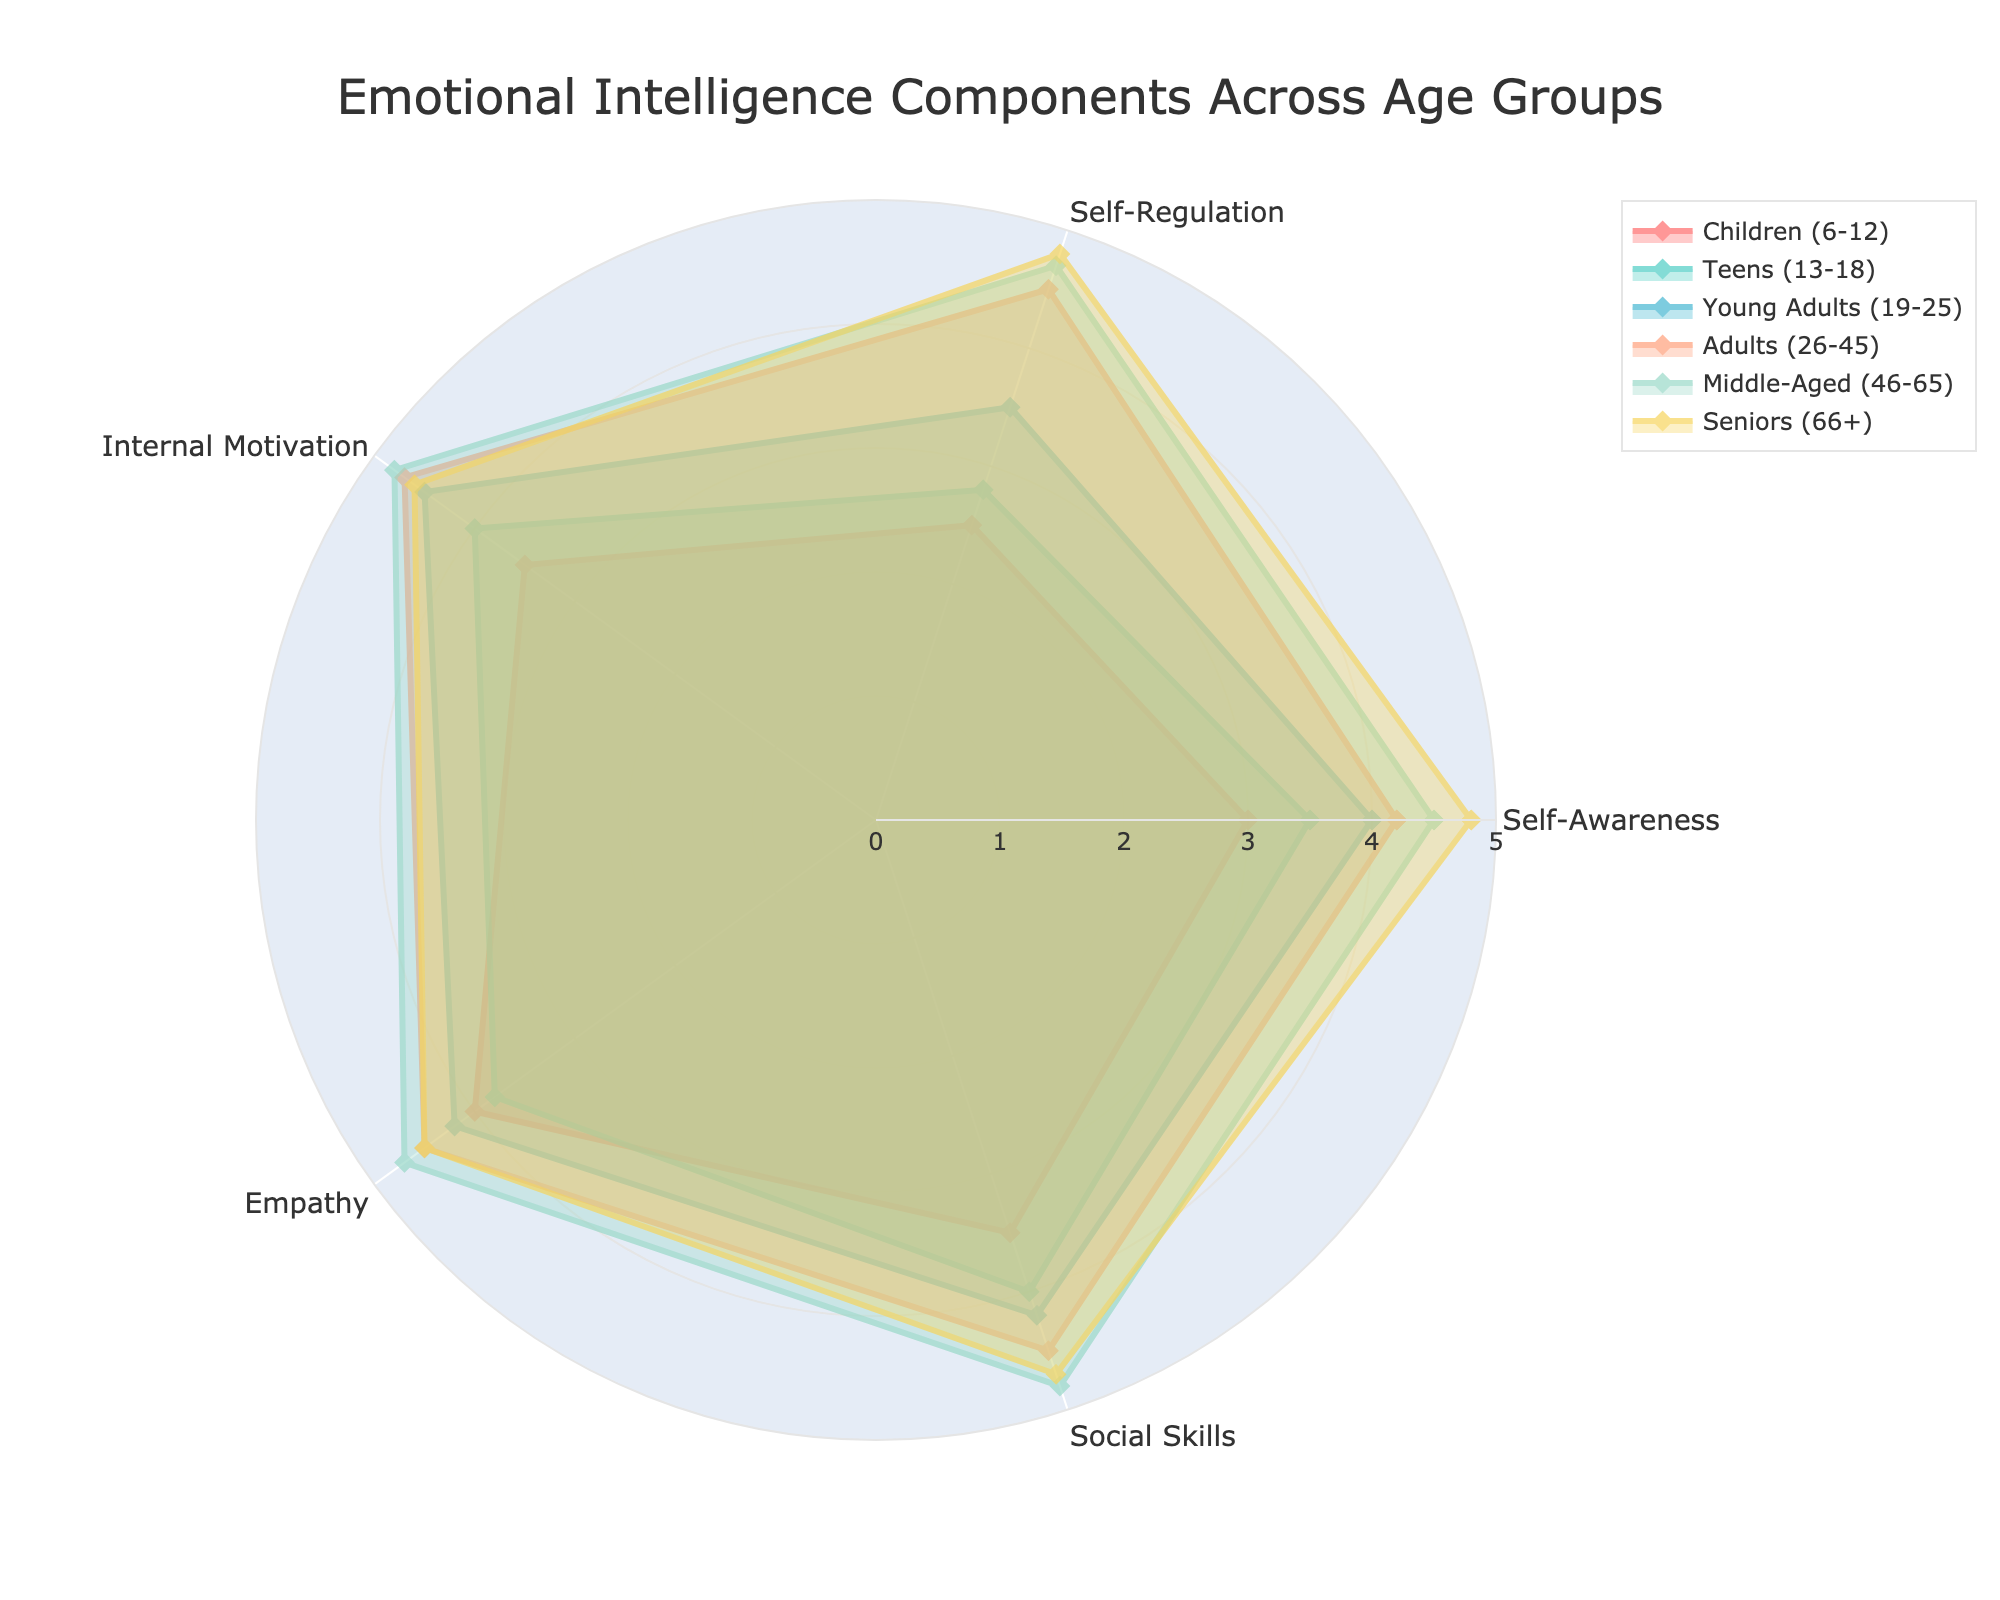What is the title of the radar chart? The title of the radar chart is centered at the top of the figure and clearly states the purpose of the chart.
Answer: Emotional Intelligence Components Across Age Groups Which age group has the highest value for self-awareness? By examining the radar chart, the group with the highest peak on the "Self-Awareness" axis can be identified.
Answer: Seniors (66+) How many axes are there in the radar chart? The number of axes corresponds to the number of emotional intelligence components listed in the data.
Answer: 5 What is the range of values for the radial axis in the radar chart? The values of the radial axis spread from the center to the outer edge. The minimum and maximum values can be deduced from the visual guidelines in the chart.
Answer: 0 to 5 Which age group has the lowest value in self-regulation? The age group with the lowest value for "Self-Regulation" can be identified by locating the smallest value on the self-regulation axis.
Answer: Children (6-12) Order the age groups based on their internal motivation values from highest to lowest. By comparing the values of "Internal Motivation" for all age groups and ranking them accordingly: Middle-Aged (46-65), Adults (26-45), Young Adults (19-25), Teens (13-18), Seniors (66+), Children (6-12).
Answer: Middle-Aged (46-65), Adults (26-45), Young Adults (19-25), Teens (13-18), Seniors (66+), Children (6-12) Which age group has the most balanced overall emotional intelligence across all components? A balanced emotional intelligence would mean similar values across all components, resulting in a more circular shape in the radar chart.
Answer: Adults (26-45) Compare the empathy levels of Middle-Aged and Teens. Which is higher, and by how much? By examining the "Empathy" axis, the values for Middle-Aged and Teens can be compared to find the difference.
Answer: Middle-Aged is higher by 0.9 Which two age groups have the most similar emotional intelligence profiles? The two age groups whose plots on the radar chart appear most similar in shape and size can be identified through visual inspection.
Answer: Middle-Aged (46-65) and Seniors (66+) What is the average social skills value for all age groups combined? By adding up the "Social Skills" values for all age groups and dividing by the number of groups: (3.5 + 4 + 4.2 + 4.5 + 4.8 + 4.7) / 6 = 25.7 / 6.
Answer: 4.28 